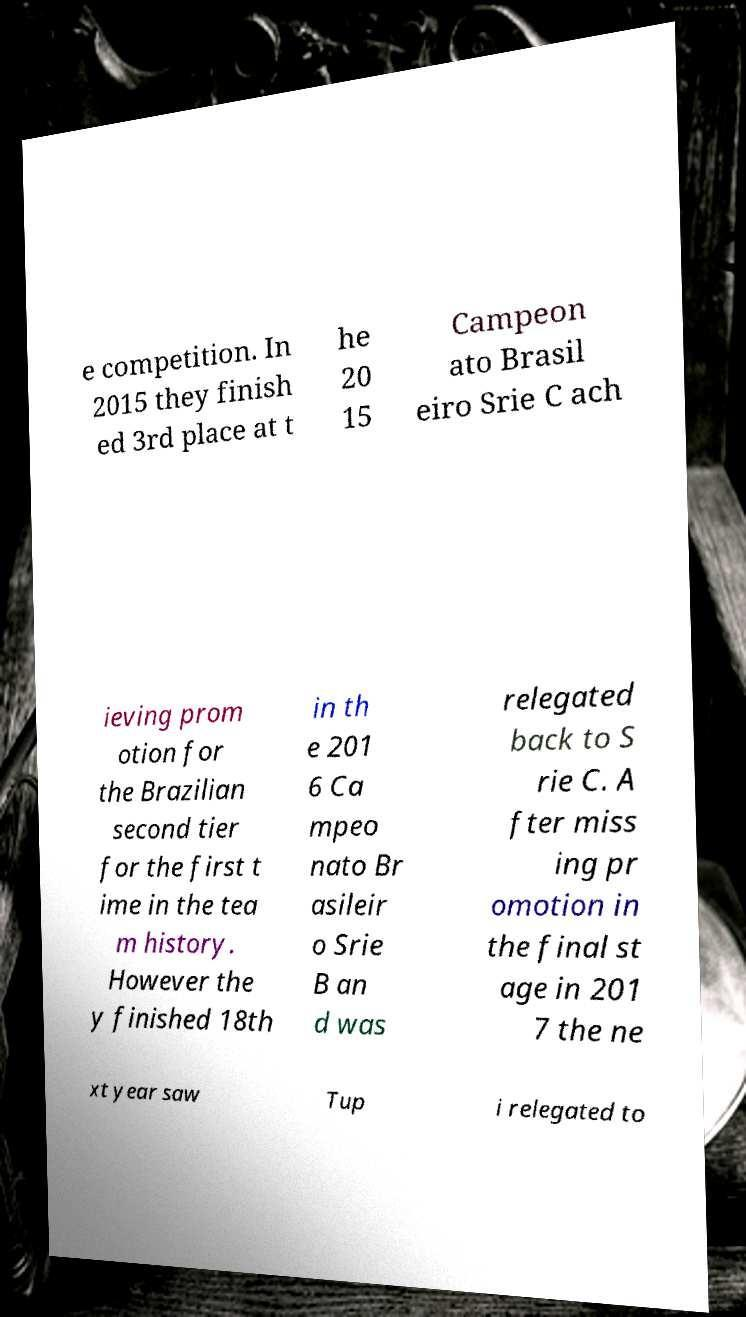Please read and relay the text visible in this image. What does it say? e competition. In 2015 they finish ed 3rd place at t he 20 15 Campeon ato Brasil eiro Srie C ach ieving prom otion for the Brazilian second tier for the first t ime in the tea m history. However the y finished 18th in th e 201 6 Ca mpeo nato Br asileir o Srie B an d was relegated back to S rie C. A fter miss ing pr omotion in the final st age in 201 7 the ne xt year saw Tup i relegated to 